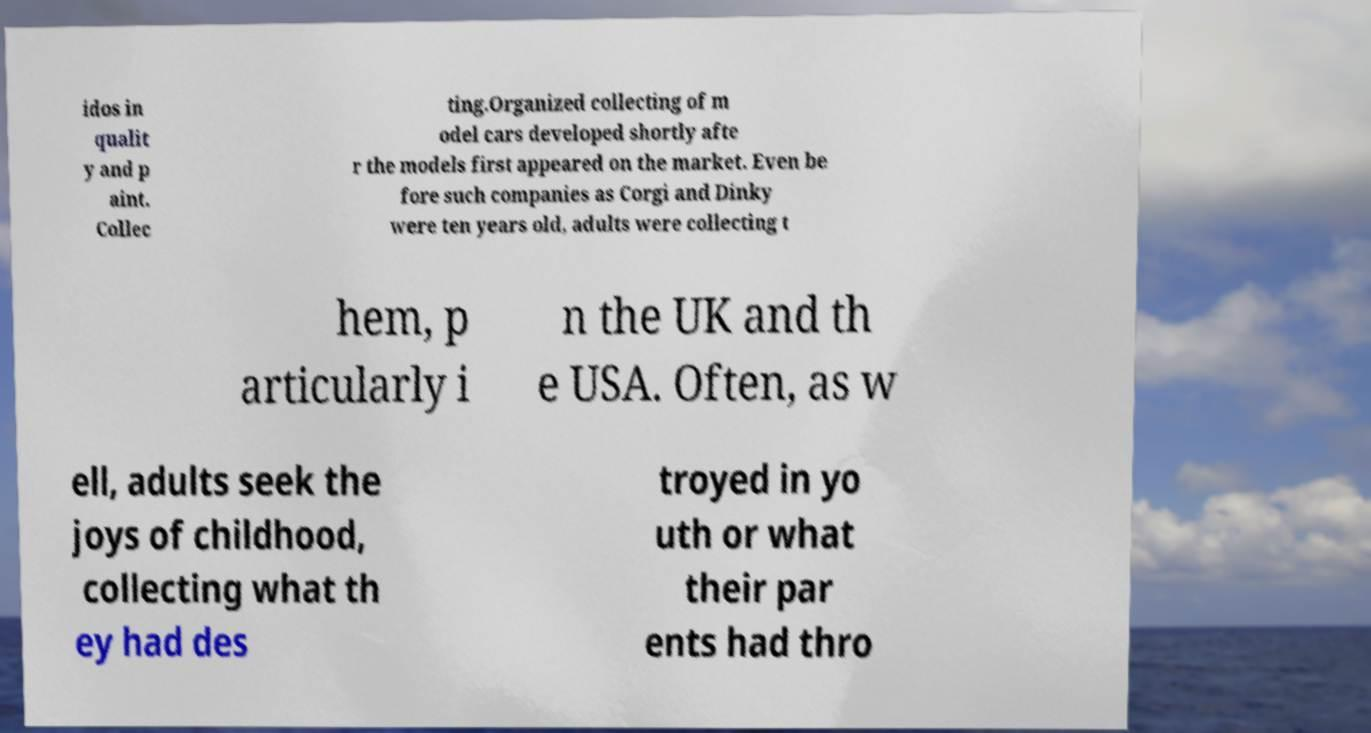For documentation purposes, I need the text within this image transcribed. Could you provide that? idos in qualit y and p aint. Collec ting.Organized collecting of m odel cars developed shortly afte r the models first appeared on the market. Even be fore such companies as Corgi and Dinky were ten years old, adults were collecting t hem, p articularly i n the UK and th e USA. Often, as w ell, adults seek the joys of childhood, collecting what th ey had des troyed in yo uth or what their par ents had thro 